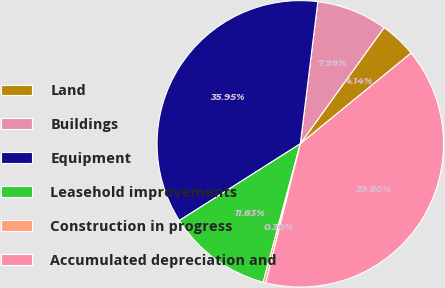Convert chart. <chart><loc_0><loc_0><loc_500><loc_500><pie_chart><fcel>Land<fcel>Buildings<fcel>Equipment<fcel>Leasehold improvements<fcel>Construction in progress<fcel>Accumulated depreciation and<nl><fcel>4.14%<fcel>7.99%<fcel>35.95%<fcel>11.83%<fcel>0.3%<fcel>39.8%<nl></chart> 